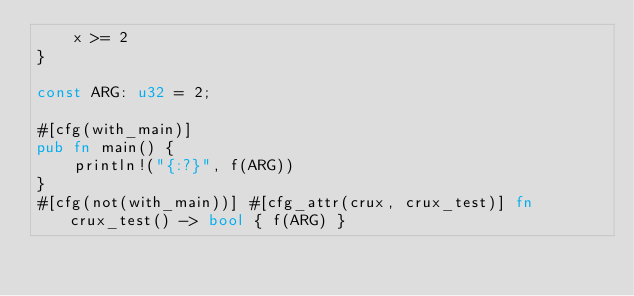<code> <loc_0><loc_0><loc_500><loc_500><_Rust_>    x >= 2
}

const ARG: u32 = 2;

#[cfg(with_main)]
pub fn main() {
    println!("{:?}", f(ARG))
}
#[cfg(not(with_main))] #[cfg_attr(crux, crux_test)] fn crux_test() -> bool { f(ARG) }
</code> 